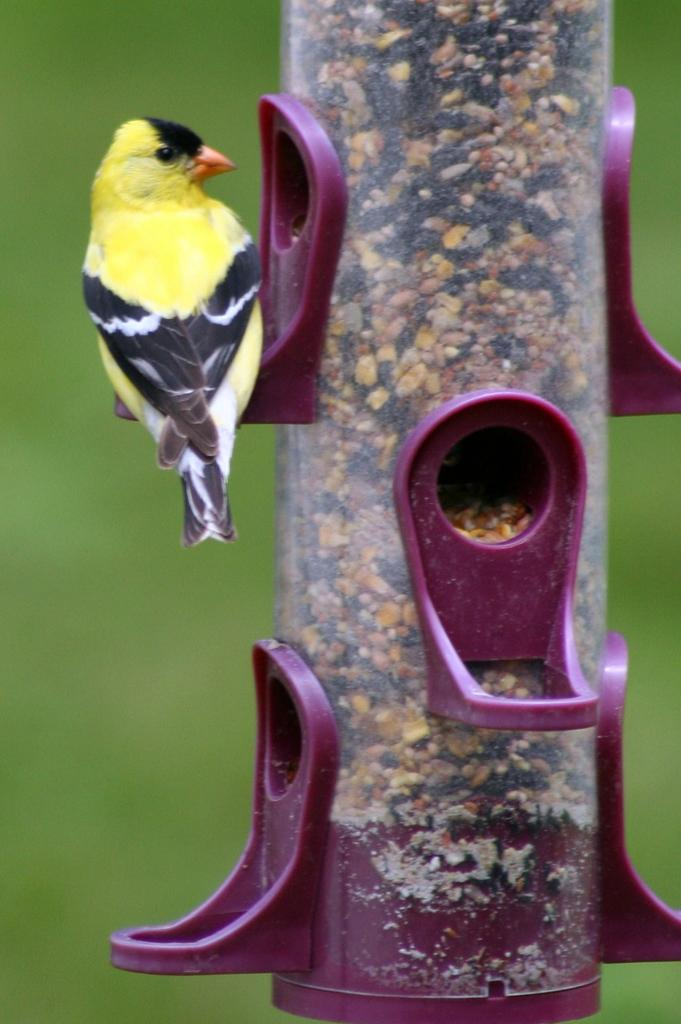What type of animal is present in the image? There is a bird in the image. What is the bird interacting with in the image? There is a bird feeder in the image. Can you describe the background of the image? The background of the image is blurry. How many apples are hanging from the wire in the image? There is no wire or apples present in the image. What advice might the bird's aunt give in the image? There is no aunt present in the image, so it is not possible to determine what advice she might give. 